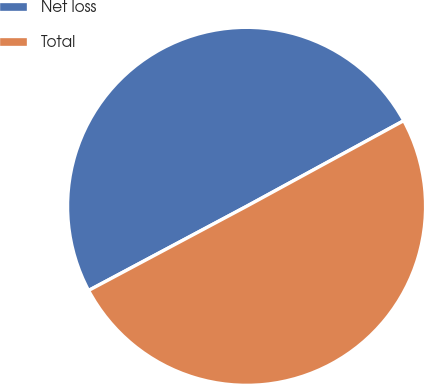Convert chart. <chart><loc_0><loc_0><loc_500><loc_500><pie_chart><fcel>Net loss<fcel>Total<nl><fcel>49.85%<fcel>50.15%<nl></chart> 